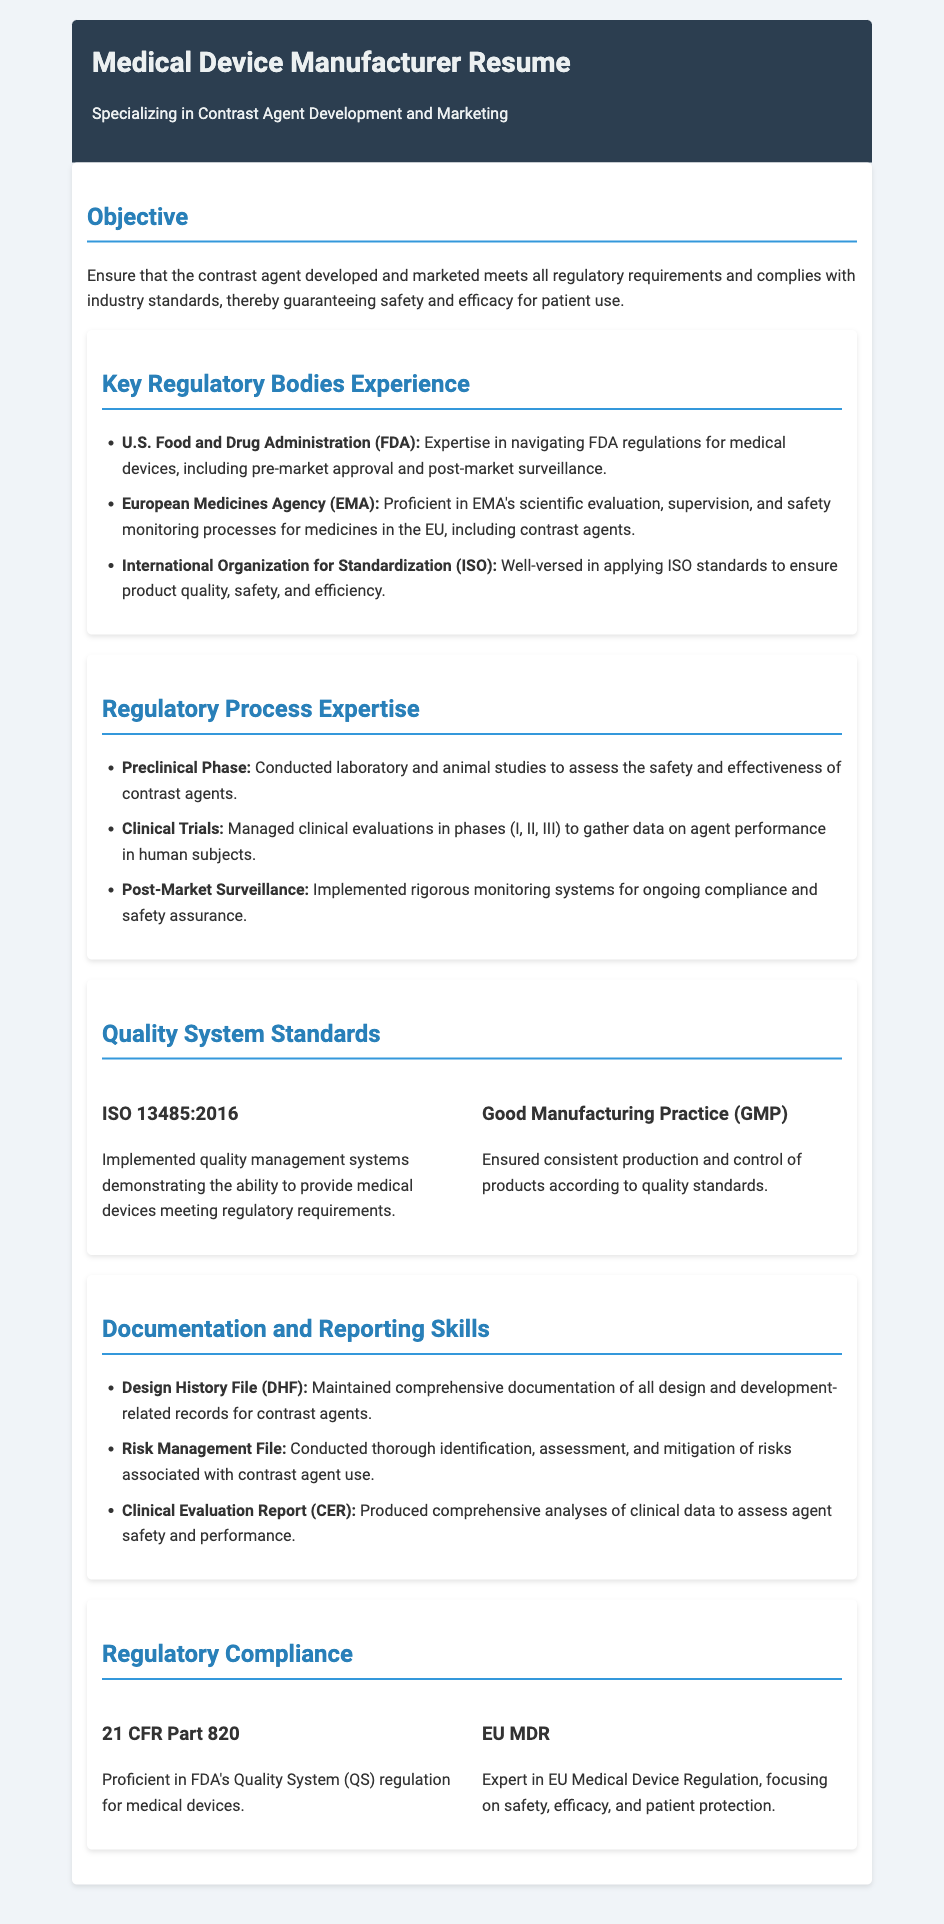What is the primary objective stated in the resume? The objective emphasizes ensuring the contrast agent meets regulatory requirements and complies with industry standards.
Answer: Ensure that the contrast agent developed and marketed meets all regulatory requirements and complies with industry standards, thereby guaranteeing safety and efficacy for patient use Which regulatory body is mentioned first in the experience section? The list of key regulatory bodies starts with the U.S. Food and Drug Administration.
Answer: U.S. Food and Drug Administration (FDA) What regulatory process is associated with laboratory and animal studies? The preclinical phase involves conducting studies to assess safety and effectiveness.
Answer: Conducted laboratory and animal studies to assess the safety and effectiveness of contrast agents What quality system standard is mentioned alongside Good Manufacturing Practice? ISO 13485:2016 is the quality system standard mentioned.
Answer: ISO 13485:2016 What is included in the Documentation and Reporting Skills section? The section lists Design History File, Risk Management File, and Clinical Evaluation Report as key skills.
Answer: Design History File (DHF), Risk Management File, Clinical Evaluation Report (CER) What does FDA's QS regulation cover? The regulation pertains to quality systems for medical devices.
Answer: 21 CFR Part 820 What regulatory aspect does the EU MDR focus on? The EU MDR emphasizes safety, efficacy, and patient protection.
Answer: safety, efficacy, and patient protection 